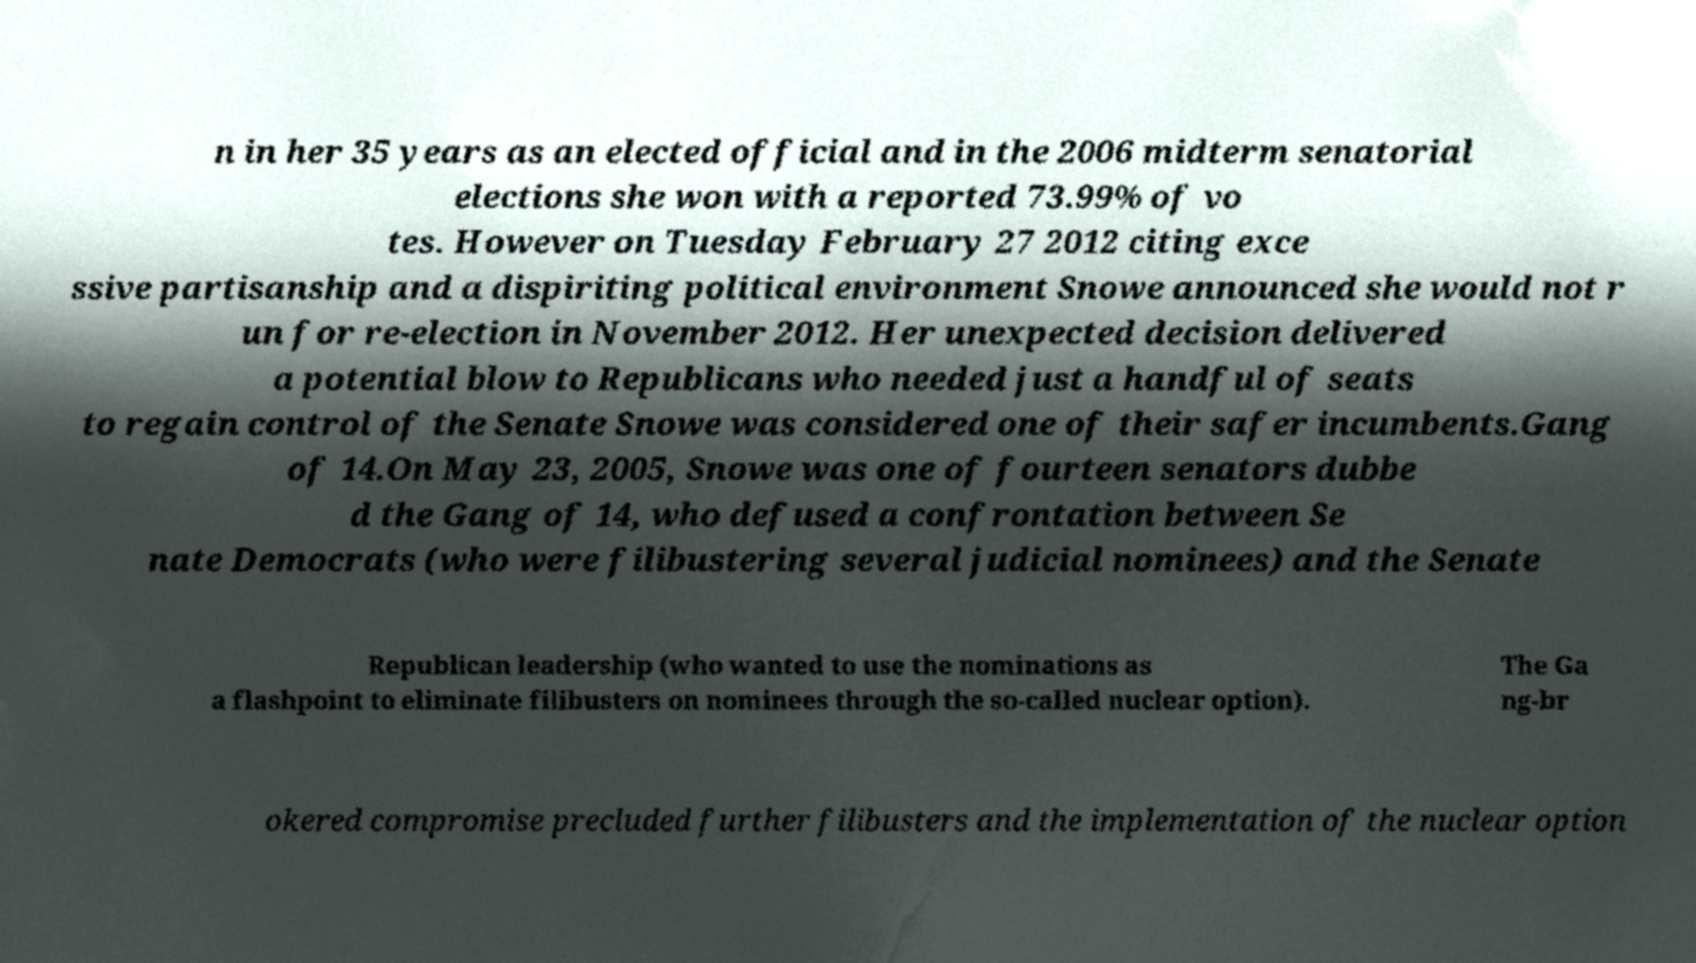There's text embedded in this image that I need extracted. Can you transcribe it verbatim? n in her 35 years as an elected official and in the 2006 midterm senatorial elections she won with a reported 73.99% of vo tes. However on Tuesday February 27 2012 citing exce ssive partisanship and a dispiriting political environment Snowe announced she would not r un for re-election in November 2012. Her unexpected decision delivered a potential blow to Republicans who needed just a handful of seats to regain control of the Senate Snowe was considered one of their safer incumbents.Gang of 14.On May 23, 2005, Snowe was one of fourteen senators dubbe d the Gang of 14, who defused a confrontation between Se nate Democrats (who were filibustering several judicial nominees) and the Senate Republican leadership (who wanted to use the nominations as a flashpoint to eliminate filibusters on nominees through the so-called nuclear option). The Ga ng-br okered compromise precluded further filibusters and the implementation of the nuclear option 